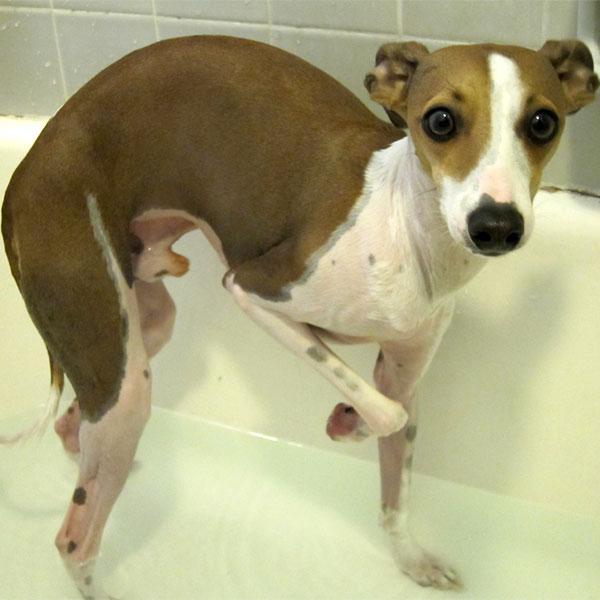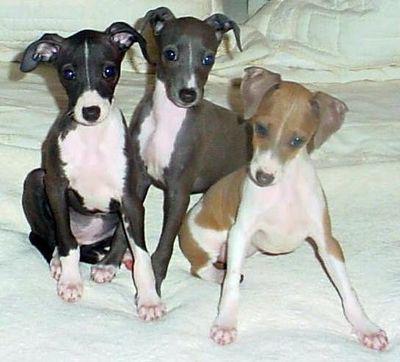The first image is the image on the left, the second image is the image on the right. Assess this claim about the two images: "There are more hound dogs in the right image than in the left.". Correct or not? Answer yes or no. Yes. The first image is the image on the left, the second image is the image on the right. Analyze the images presented: Is the assertion "One of the dogs is in green vegetation." valid? Answer yes or no. No. 